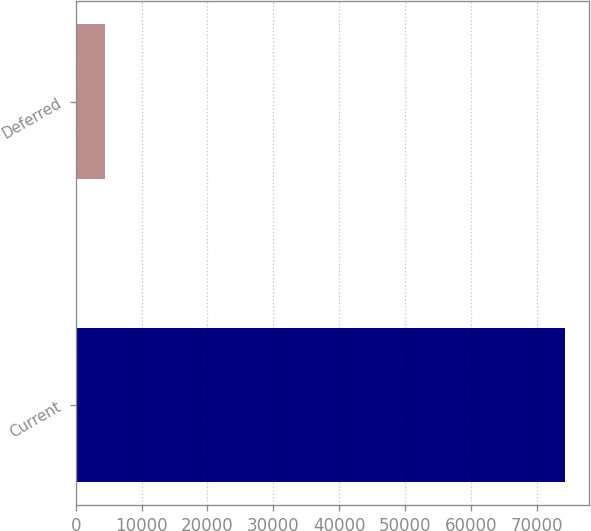<chart> <loc_0><loc_0><loc_500><loc_500><bar_chart><fcel>Current<fcel>Deferred<nl><fcel>74311<fcel>4447<nl></chart> 